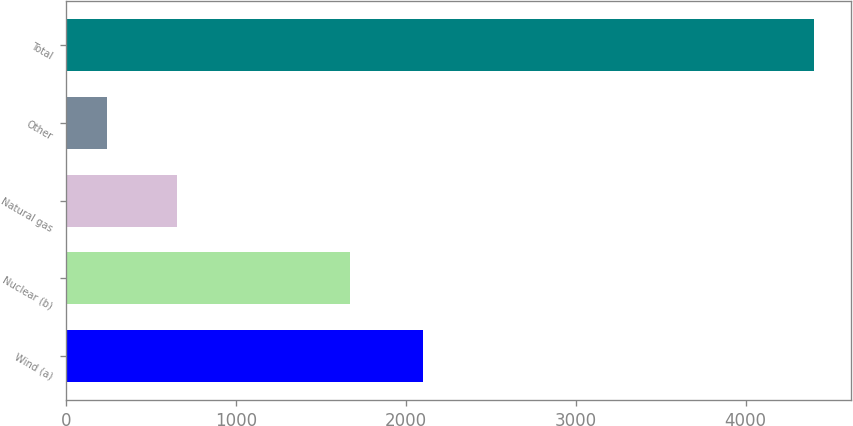Convert chart to OTSL. <chart><loc_0><loc_0><loc_500><loc_500><bar_chart><fcel>Wind (a)<fcel>Nuclear (b)<fcel>Natural gas<fcel>Other<fcel>Total<nl><fcel>2100<fcel>1675<fcel>656<fcel>240<fcel>4400<nl></chart> 